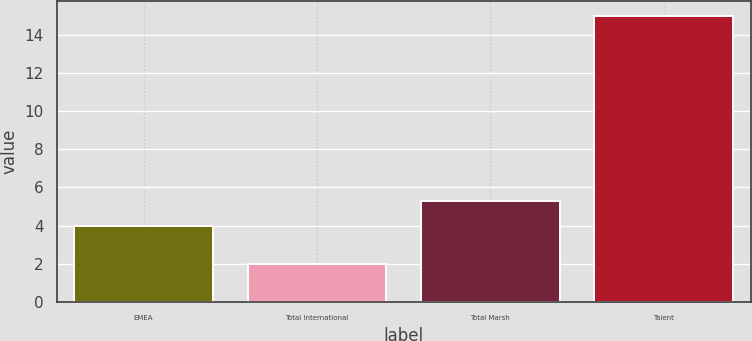Convert chart. <chart><loc_0><loc_0><loc_500><loc_500><bar_chart><fcel>EMEA<fcel>Total International<fcel>Total Marsh<fcel>Talent<nl><fcel>4<fcel>2<fcel>5.3<fcel>15<nl></chart> 